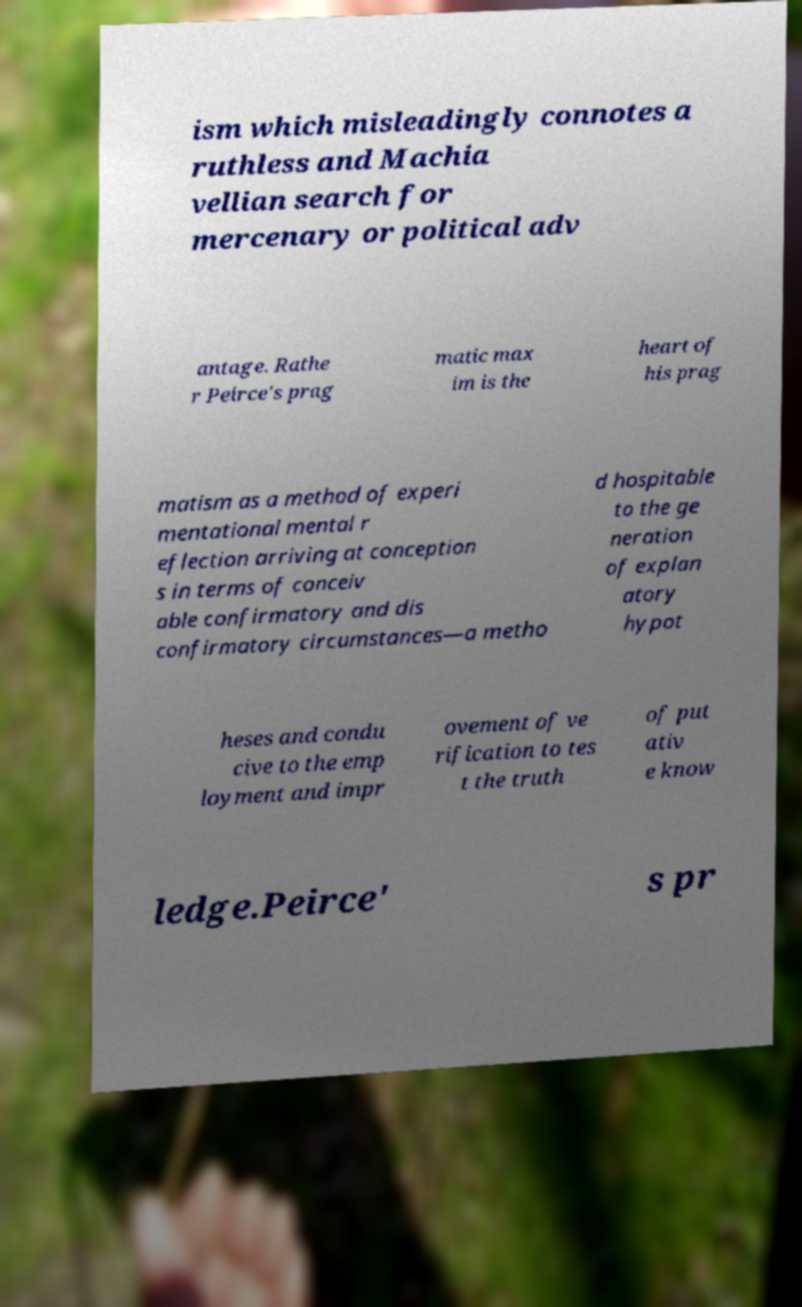Could you extract and type out the text from this image? ism which misleadingly connotes a ruthless and Machia vellian search for mercenary or political adv antage. Rathe r Peirce's prag matic max im is the heart of his prag matism as a method of experi mentational mental r eflection arriving at conception s in terms of conceiv able confirmatory and dis confirmatory circumstances—a metho d hospitable to the ge neration of explan atory hypot heses and condu cive to the emp loyment and impr ovement of ve rification to tes t the truth of put ativ e know ledge.Peirce' s pr 